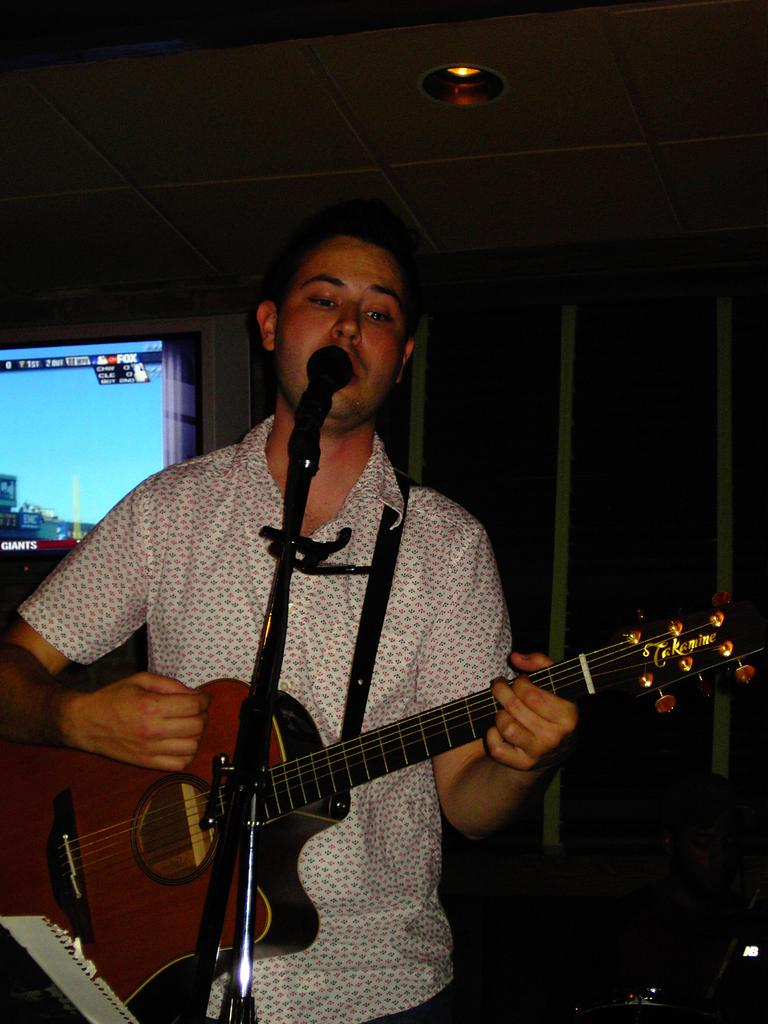Who is the main subject in the image? There is a boy in the image. What is the boy doing in the image? The boy is standing and singing a song. What object is the boy holding in his hand? The boy is holding a guitar in his hand. What can be seen behind the boy in the image? There is a screen behind the boy. What type of wool is being used to control the boy's movements in the image? There is no wool or control mechanism present in the image; the boy is singing and holding a guitar on his own. 